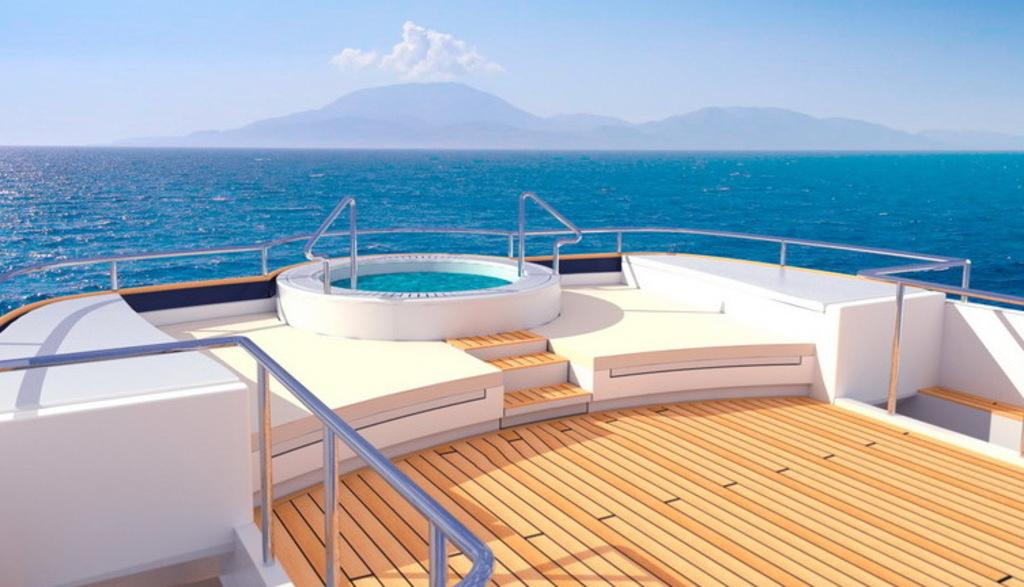What is the main subject of the picture? The main subject of the picture is a boat. What unique feature does the boat have? The boat has a swimming pool. What type of environment is the boat in? There is water visible in the image, and there are hills in the background. How would you describe the sky in the picture? The sky is blue and cloudy. Can you tell me when the baby was born in the image? There is no baby or mention of a birth in the image; it features a boat with a swimming pool. How many rays are visible in the image? There are no rays present in the image; it shows a boat, water, hills, and a blue, cloudy sky. 